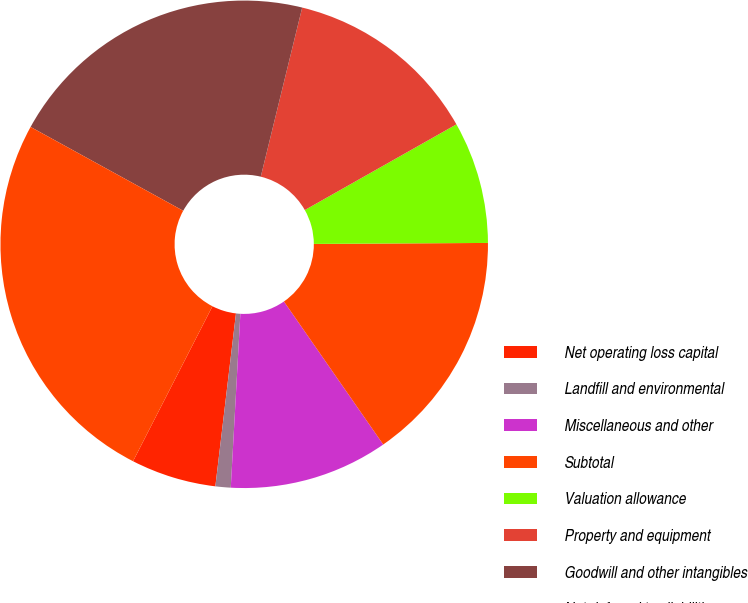<chart> <loc_0><loc_0><loc_500><loc_500><pie_chart><fcel>Net operating loss capital<fcel>Landfill and environmental<fcel>Miscellaneous and other<fcel>Subtotal<fcel>Valuation allowance<fcel>Property and equipment<fcel>Goodwill and other intangibles<fcel>Net deferred tax liabilities<nl><fcel>5.65%<fcel>1.01%<fcel>10.54%<fcel>15.43%<fcel>8.1%<fcel>12.99%<fcel>20.83%<fcel>25.46%<nl></chart> 